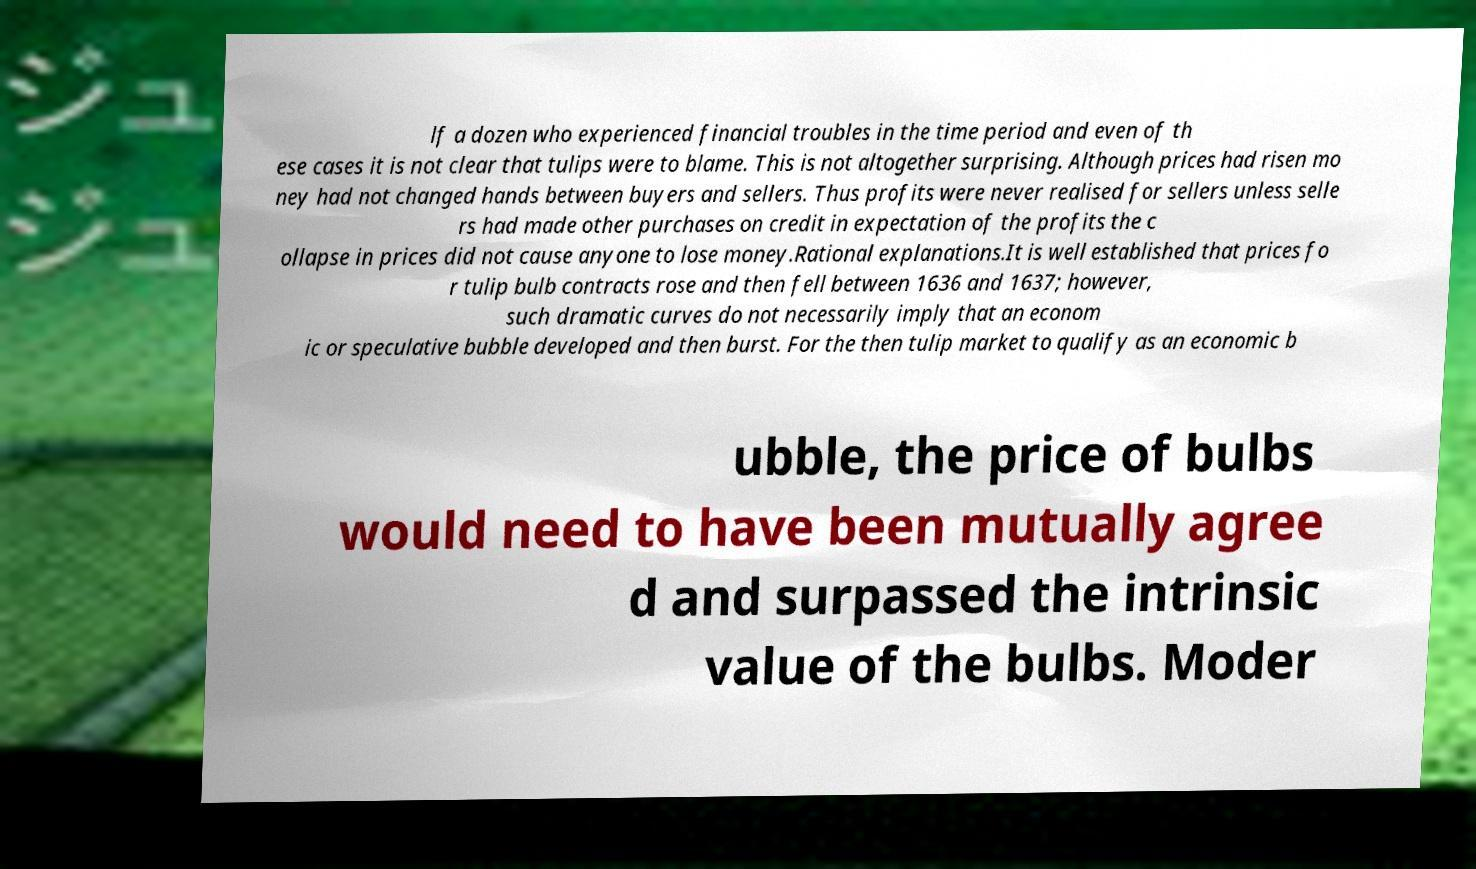There's text embedded in this image that I need extracted. Can you transcribe it verbatim? lf a dozen who experienced financial troubles in the time period and even of th ese cases it is not clear that tulips were to blame. This is not altogether surprising. Although prices had risen mo ney had not changed hands between buyers and sellers. Thus profits were never realised for sellers unless selle rs had made other purchases on credit in expectation of the profits the c ollapse in prices did not cause anyone to lose money.Rational explanations.It is well established that prices fo r tulip bulb contracts rose and then fell between 1636 and 1637; however, such dramatic curves do not necessarily imply that an econom ic or speculative bubble developed and then burst. For the then tulip market to qualify as an economic b ubble, the price of bulbs would need to have been mutually agree d and surpassed the intrinsic value of the bulbs. Moder 